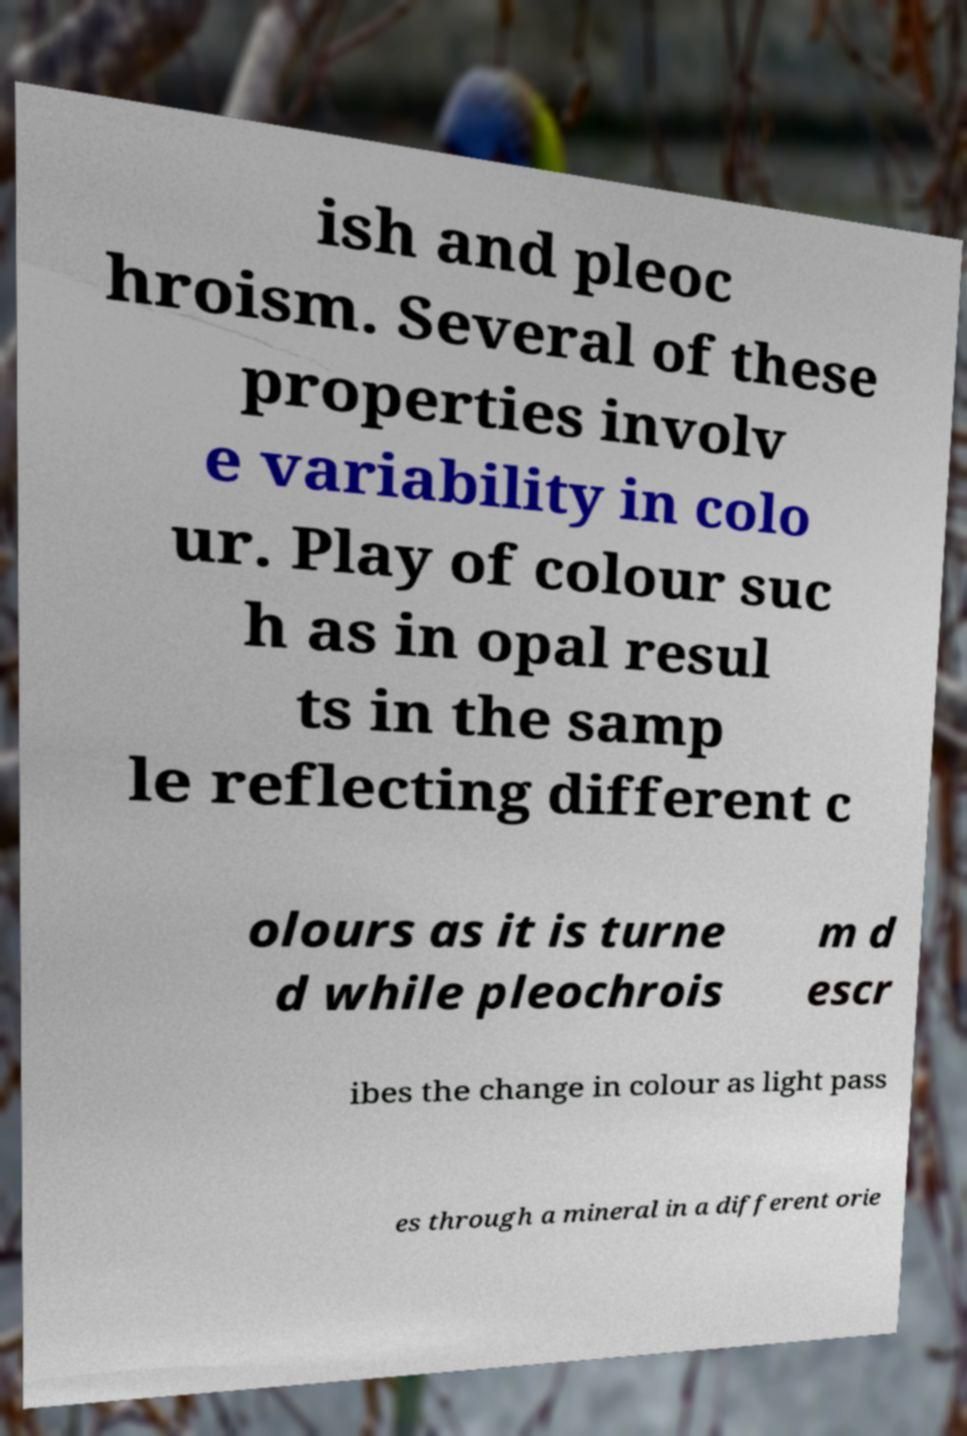Can you accurately transcribe the text from the provided image for me? ish and pleoc hroism. Several of these properties involv e variability in colo ur. Play of colour suc h as in opal resul ts in the samp le reflecting different c olours as it is turne d while pleochrois m d escr ibes the change in colour as light pass es through a mineral in a different orie 